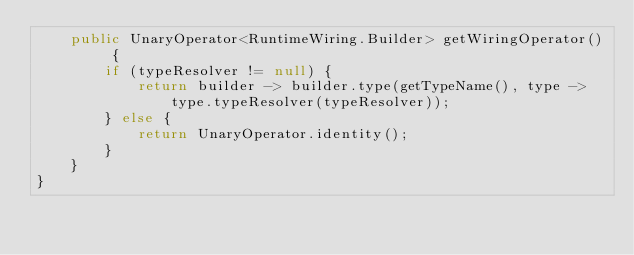Convert code to text. <code><loc_0><loc_0><loc_500><loc_500><_Java_>    public UnaryOperator<RuntimeWiring.Builder> getWiringOperator() {
        if (typeResolver != null) {
            return builder -> builder.type(getTypeName(), type -> type.typeResolver(typeResolver));
        } else {
            return UnaryOperator.identity();
        }
    }
}
</code> 